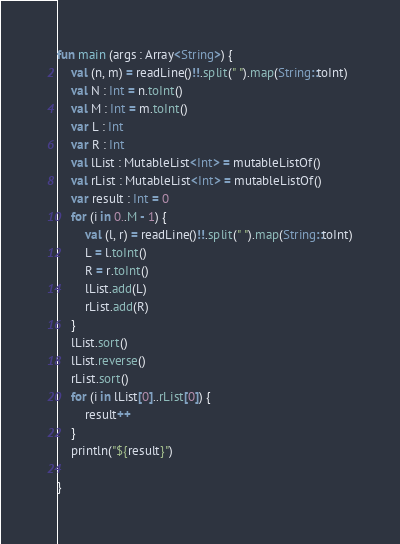Convert code to text. <code><loc_0><loc_0><loc_500><loc_500><_Kotlin_>fun main (args : Array<String>) {
	val (n, m) = readLine()!!.split(" ").map(String::toInt)
	val N : Int = n.toInt()
	val M : Int = m.toInt()
	var L : Int
	var R : Int
	val lList : MutableList<Int> = mutableListOf()
	val rList : MutableList<Int> = mutableListOf()
	var result : Int = 0
	for (i in 0..M - 1) {
		val (l, r) = readLine()!!.split(" ").map(String::toInt)
		L = l.toInt()
		R = r.toInt()
		lList.add(L)
		rList.add(R)
	}
	lList.sort()
	lList.reverse()
	rList.sort()
	for (i in lList[0]..rList[0]) {
		result++
	}
	println("${result}")
	
}</code> 